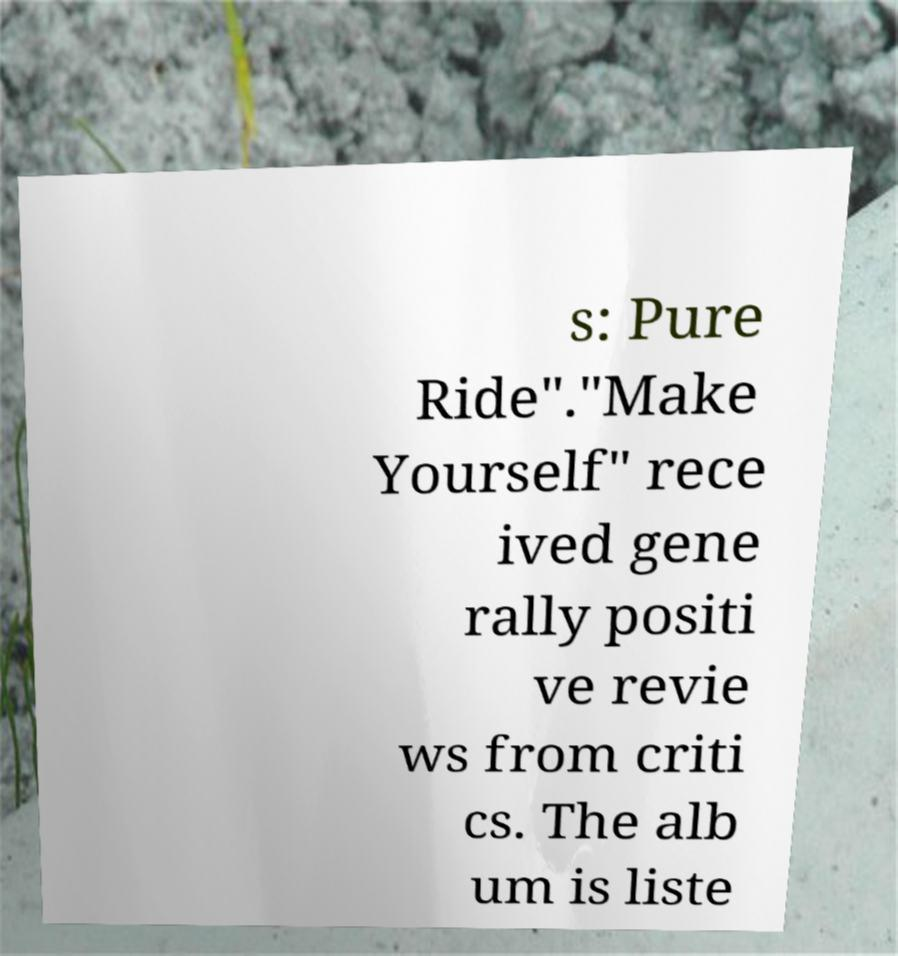There's text embedded in this image that I need extracted. Can you transcribe it verbatim? s: Pure Ride"."Make Yourself" rece ived gene rally positi ve revie ws from criti cs. The alb um is liste 